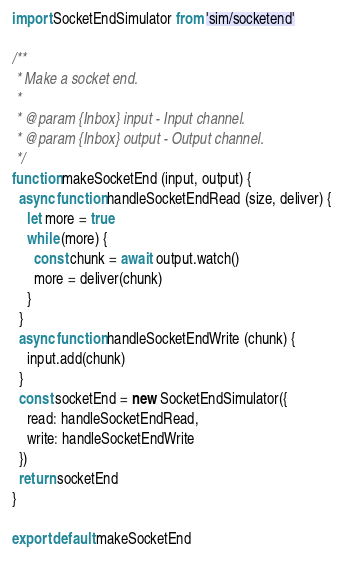Convert code to text. <code><loc_0><loc_0><loc_500><loc_500><_JavaScript_>import SocketEndSimulator from 'sim/socketend'

/**
 * Make a socket end.
 *
 * @param {Inbox} input - Input channel.
 * @param {Inbox} output - Output channel.
 */
function makeSocketEnd (input, output) {
  async function handleSocketEndRead (size, deliver) {
    let more = true
    while (more) {
      const chunk = await output.watch()
      more = deliver(chunk)
    }
  }
  async function handleSocketEndWrite (chunk) {
    input.add(chunk)
  }
  const socketEnd = new SocketEndSimulator({
    read: handleSocketEndRead,
    write: handleSocketEndWrite
  })
  return socketEnd
}

export default makeSocketEnd
</code> 